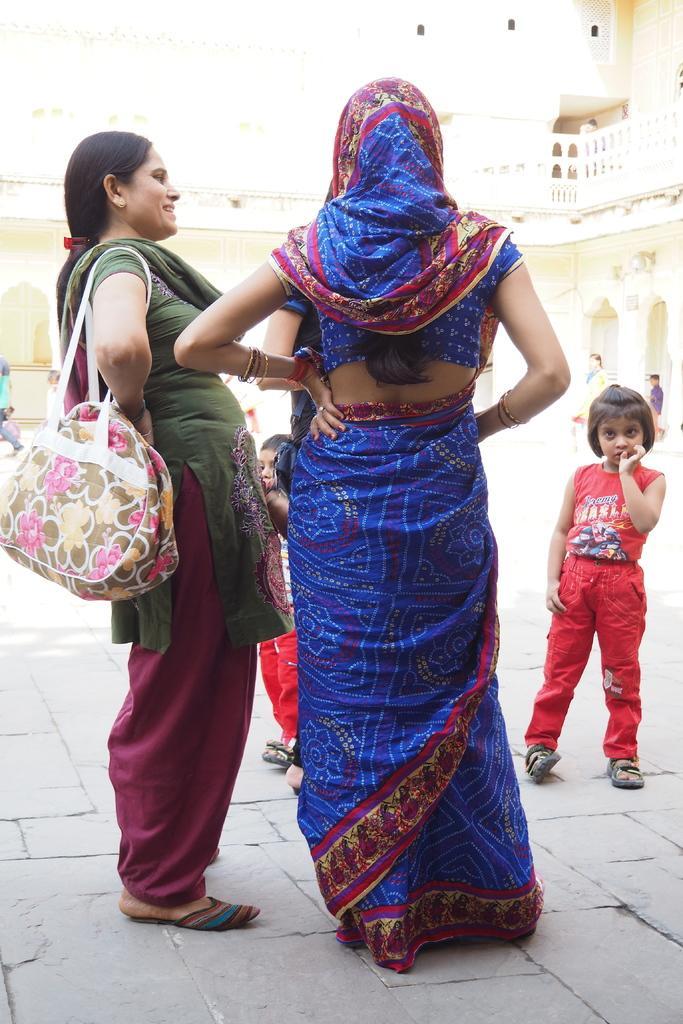Could you give a brief overview of what you see in this image? There are two women standing here. One of the woman is holding a bag on her shoulders and we can observe a child here, standing. In the background there is a building. 